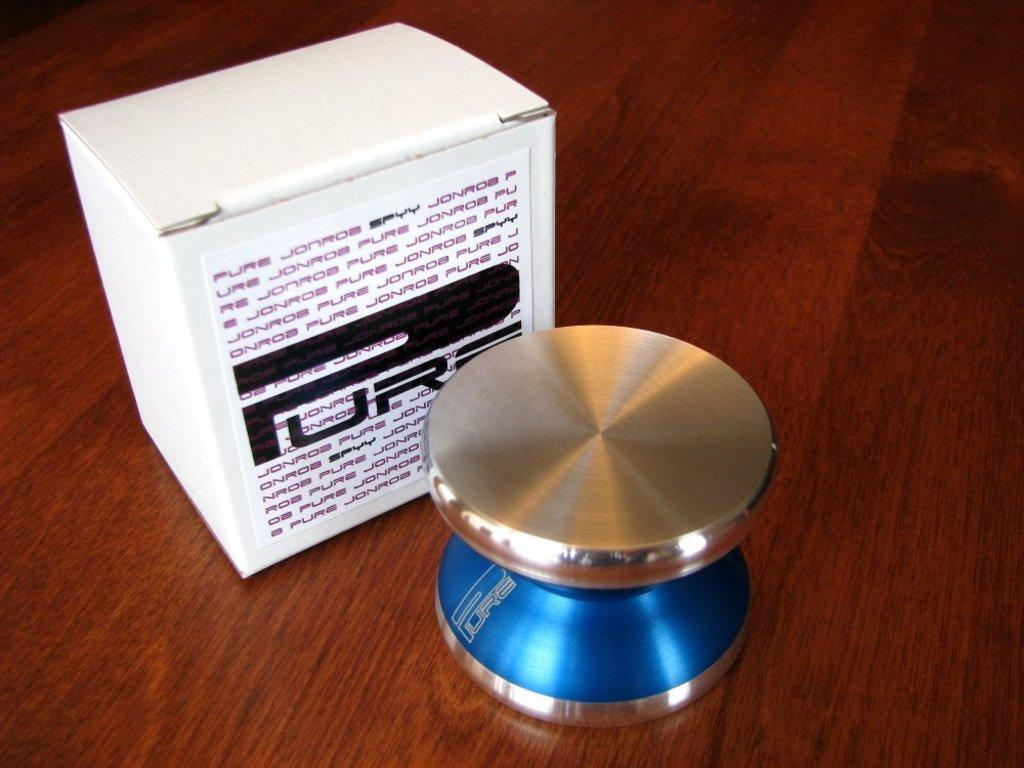<image>
Share a concise interpretation of the image provided. A white box with a PURE label on it and red and black words 